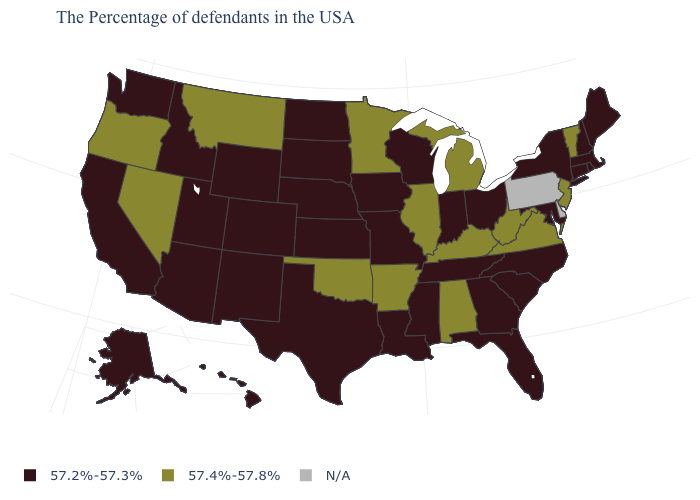What is the value of Alabama?
Keep it brief. 57.4%-57.8%. What is the value of Wisconsin?
Short answer required. 57.2%-57.3%. What is the value of Connecticut?
Quick response, please. 57.2%-57.3%. Which states hav the highest value in the MidWest?
Short answer required. Michigan, Illinois, Minnesota. How many symbols are there in the legend?
Write a very short answer. 3. Among the states that border Washington , does Idaho have the highest value?
Short answer required. No. What is the value of Mississippi?
Concise answer only. 57.2%-57.3%. What is the highest value in the USA?
Concise answer only. 57.4%-57.8%. Among the states that border Kansas , does Oklahoma have the highest value?
Answer briefly. Yes. Does the map have missing data?
Short answer required. Yes. Which states have the lowest value in the West?
Concise answer only. Wyoming, Colorado, New Mexico, Utah, Arizona, Idaho, California, Washington, Alaska, Hawaii. What is the lowest value in the Northeast?
Write a very short answer. 57.2%-57.3%. Name the states that have a value in the range 57.4%-57.8%?
Quick response, please. Vermont, New Jersey, Virginia, West Virginia, Michigan, Kentucky, Alabama, Illinois, Arkansas, Minnesota, Oklahoma, Montana, Nevada, Oregon. What is the value of Colorado?
Concise answer only. 57.2%-57.3%. How many symbols are there in the legend?
Write a very short answer. 3. 